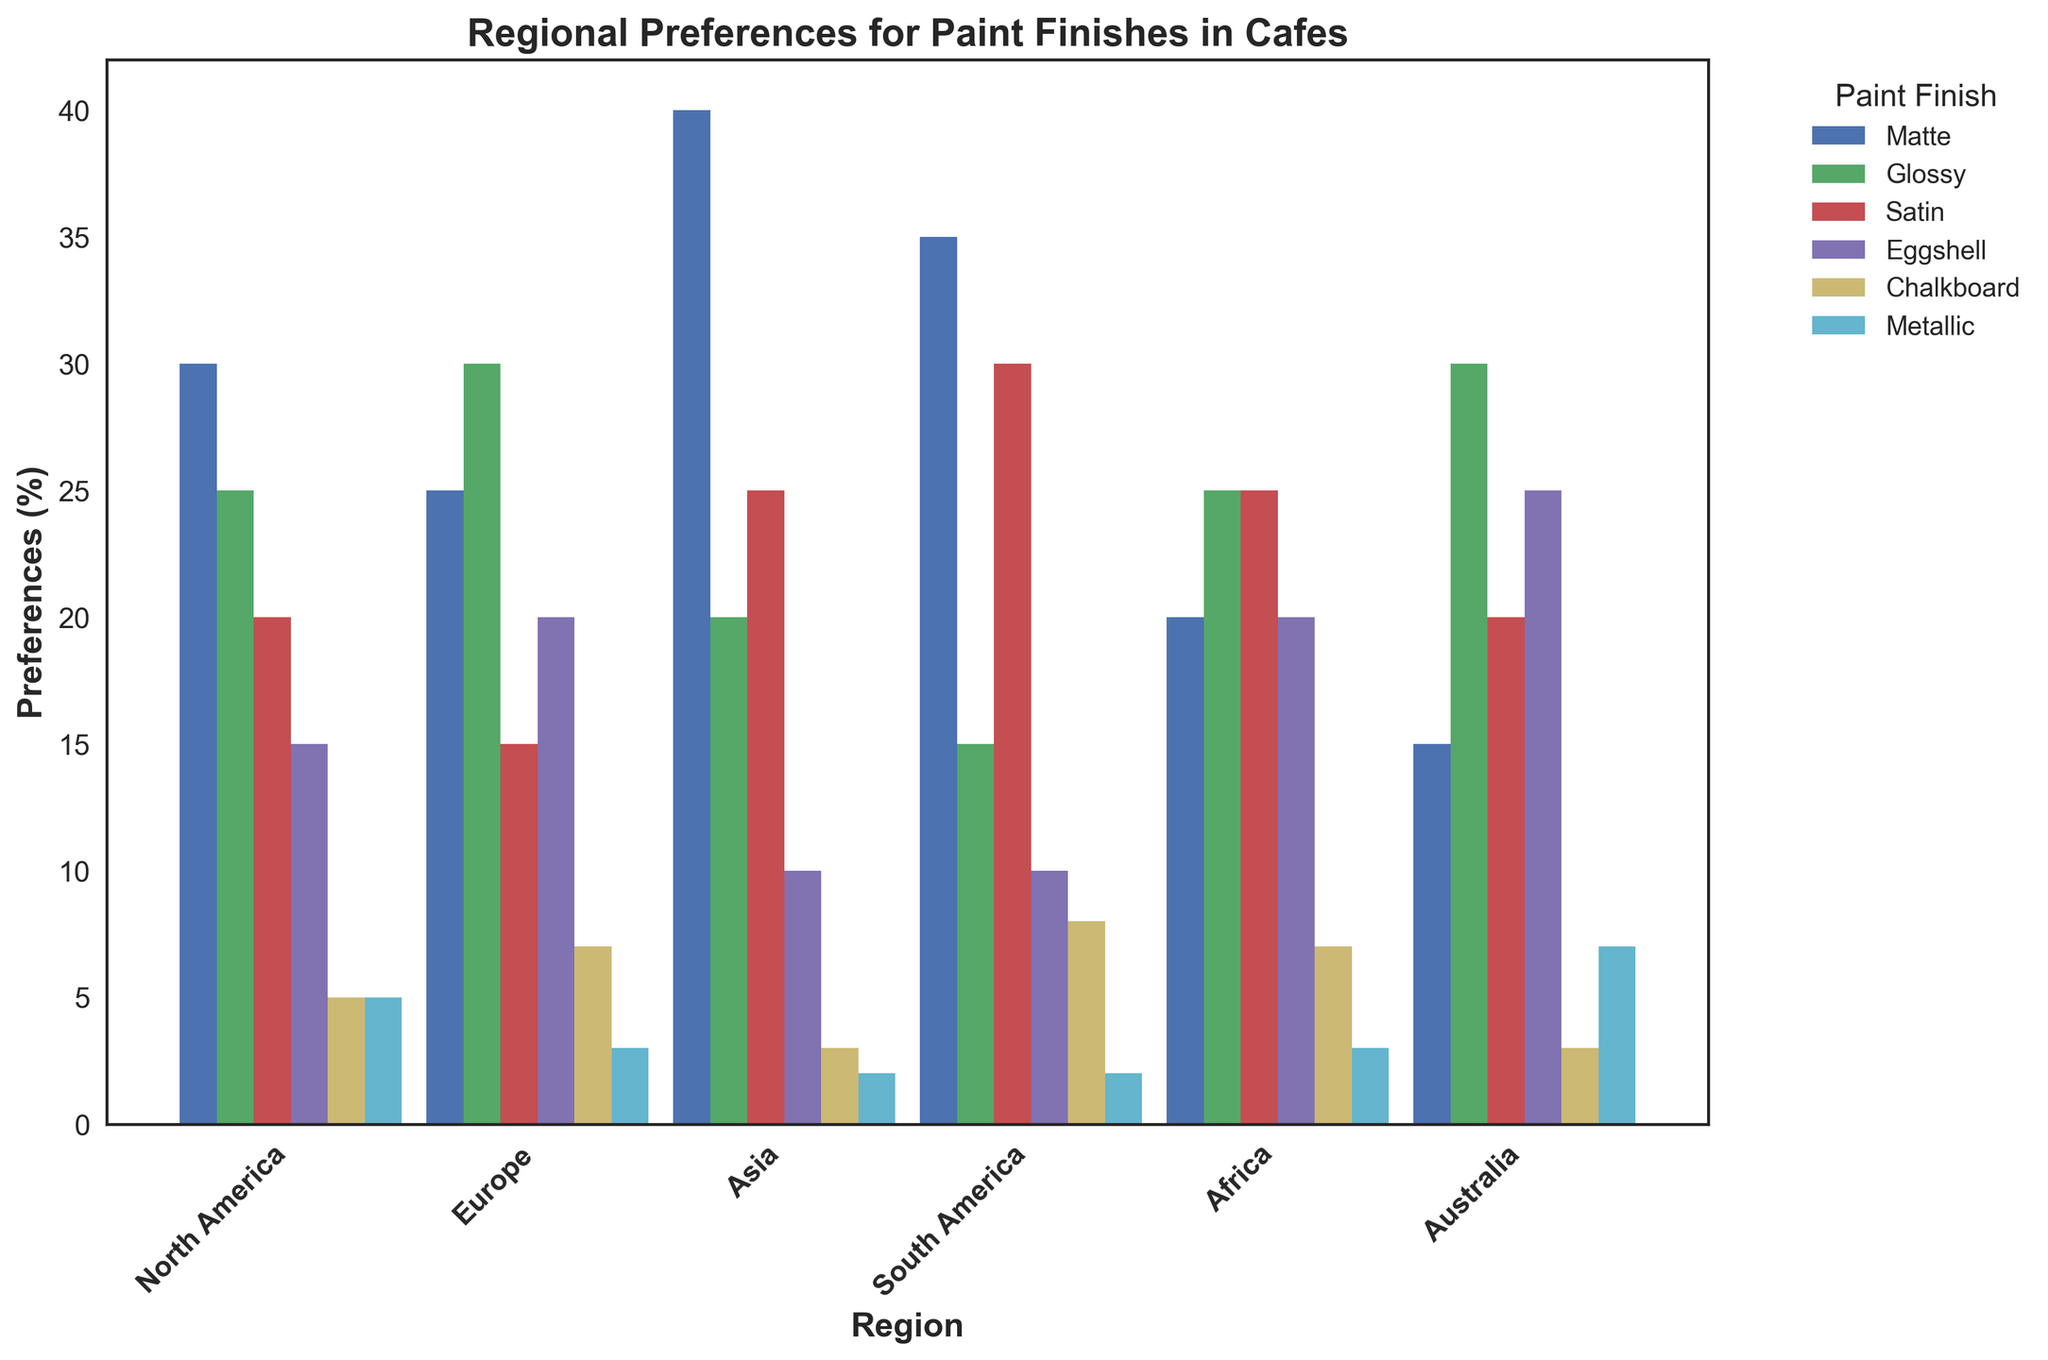Which region has the highest preference for Matte finishes? To determine the region with the highest preference for Matte finishes, look at the height of the Matte bar for each region. The highest bar corresponds to the highest preference. Based on the data, Asia has the tallest bar in the Matte category.
Answer: Asia Which finish is the most preferred in Europe? To find the most preferred finish in Europe, look at the heights of all bars for Europe. The bar with the greatest height indicates the most preferred finish. The Glossy finish has the tallest bar in Europe.
Answer: Glossy What is the total preference percentage of Matte and Glossy finishes in North America? To get the total preference percentage, add the percentages of the Matte and Glossy finishes for North America. Matte is 30% and Glossy is 25%, which sums to 55%.
Answer: 55% Compare the preference for Chalkboard finishes between South America and Africa. Which is higher? Examine the heights of the Chalkboard finish bars for South America and Africa. South America has a slightly taller bar at 8%, compared to Africa at 7%, making South America's preference higher.
Answer: South America What is the average preference for Satin finishes across all regions? To compute the average preference for Satin finishes, sum all the Satin values and divide by the number of regions. The Satin values are 20, 15, 25, 30, 25, 20. Their sum is 135, and there are 6 regions, so the average is 135/6 = 22.5%.
Answer: 22.5% Which region has the lowest preference for Metallic finishes? To identify the region with the lowest preference for Metallic finishes, observe the heights of the Metallic bars for each region. The shortest bar corresponds to Asia, with a percentage of 2%.
Answer: Asia What is the sum of preferences for Eggshell and Metallic finishes in Australia? To find the sum of preferences, add the percentages for Eggshell and Metallic finishes for Australia. Eggshell is 25% and Metallic is 7%, which together equal 32%.
Answer: 32% Is the preference for Matte finishes greater in Africa or Australia? By comparing the heights of the Matte bars in Africa and Australia, we see that Africa has a preference of 20%, whereas Australia has 15%. Hence, Africa has a higher preference.
Answer: Africa 